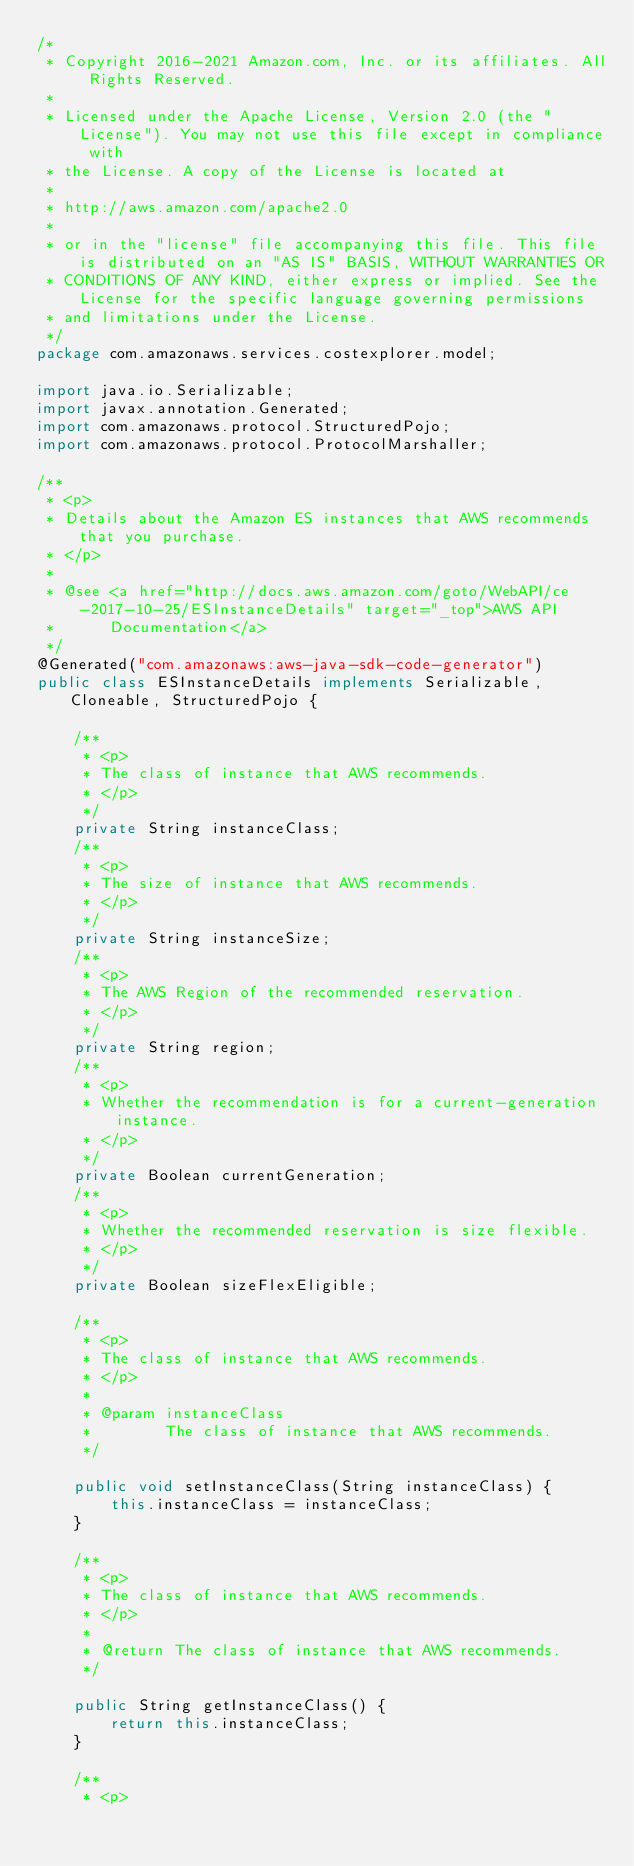Convert code to text. <code><loc_0><loc_0><loc_500><loc_500><_Java_>/*
 * Copyright 2016-2021 Amazon.com, Inc. or its affiliates. All Rights Reserved.
 * 
 * Licensed under the Apache License, Version 2.0 (the "License"). You may not use this file except in compliance with
 * the License. A copy of the License is located at
 * 
 * http://aws.amazon.com/apache2.0
 * 
 * or in the "license" file accompanying this file. This file is distributed on an "AS IS" BASIS, WITHOUT WARRANTIES OR
 * CONDITIONS OF ANY KIND, either express or implied. See the License for the specific language governing permissions
 * and limitations under the License.
 */
package com.amazonaws.services.costexplorer.model;

import java.io.Serializable;
import javax.annotation.Generated;
import com.amazonaws.protocol.StructuredPojo;
import com.amazonaws.protocol.ProtocolMarshaller;

/**
 * <p>
 * Details about the Amazon ES instances that AWS recommends that you purchase.
 * </p>
 * 
 * @see <a href="http://docs.aws.amazon.com/goto/WebAPI/ce-2017-10-25/ESInstanceDetails" target="_top">AWS API
 *      Documentation</a>
 */
@Generated("com.amazonaws:aws-java-sdk-code-generator")
public class ESInstanceDetails implements Serializable, Cloneable, StructuredPojo {

    /**
     * <p>
     * The class of instance that AWS recommends.
     * </p>
     */
    private String instanceClass;
    /**
     * <p>
     * The size of instance that AWS recommends.
     * </p>
     */
    private String instanceSize;
    /**
     * <p>
     * The AWS Region of the recommended reservation.
     * </p>
     */
    private String region;
    /**
     * <p>
     * Whether the recommendation is for a current-generation instance.
     * </p>
     */
    private Boolean currentGeneration;
    /**
     * <p>
     * Whether the recommended reservation is size flexible.
     * </p>
     */
    private Boolean sizeFlexEligible;

    /**
     * <p>
     * The class of instance that AWS recommends.
     * </p>
     * 
     * @param instanceClass
     *        The class of instance that AWS recommends.
     */

    public void setInstanceClass(String instanceClass) {
        this.instanceClass = instanceClass;
    }

    /**
     * <p>
     * The class of instance that AWS recommends.
     * </p>
     * 
     * @return The class of instance that AWS recommends.
     */

    public String getInstanceClass() {
        return this.instanceClass;
    }

    /**
     * <p></code> 